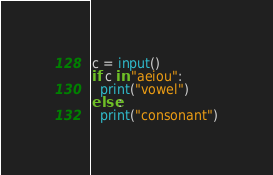<code> <loc_0><loc_0><loc_500><loc_500><_Python_>c = input()
if c in "aeiou":
  print("vowel")
else:
  print("consonant")</code> 